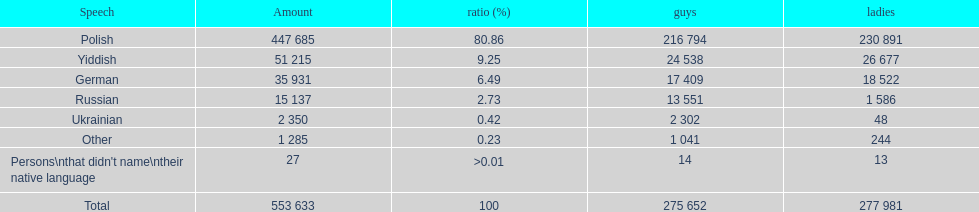How many people didn't name their native language? 27. 